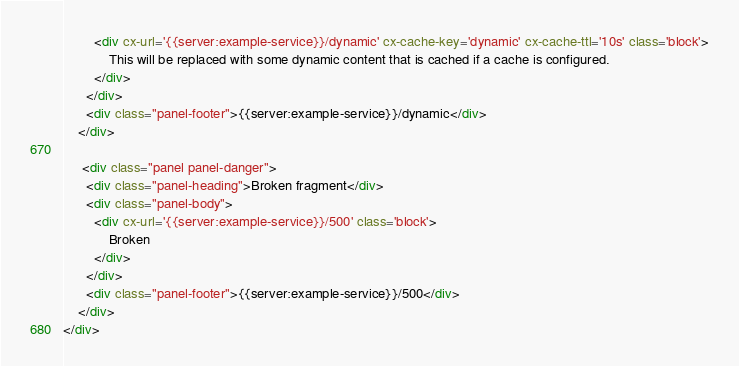<code> <loc_0><loc_0><loc_500><loc_500><_HTML_>        <div cx-url='{{server:example-service}}/dynamic' cx-cache-key='dynamic' cx-cache-ttl='10s' class='block'>
            This will be replaced with some dynamic content that is cached if a cache is configured.
        </div>
      </div>
      <div class="panel-footer">{{server:example-service}}/dynamic</div>
    </div>

     <div class="panel panel-danger">
      <div class="panel-heading">Broken fragment</div>
      <div class="panel-body">
        <div cx-url='{{server:example-service}}/500' class='block'>
            Broken
        </div>
      </div>
      <div class="panel-footer">{{server:example-service}}/500</div>
    </div>
</div>
</code> 